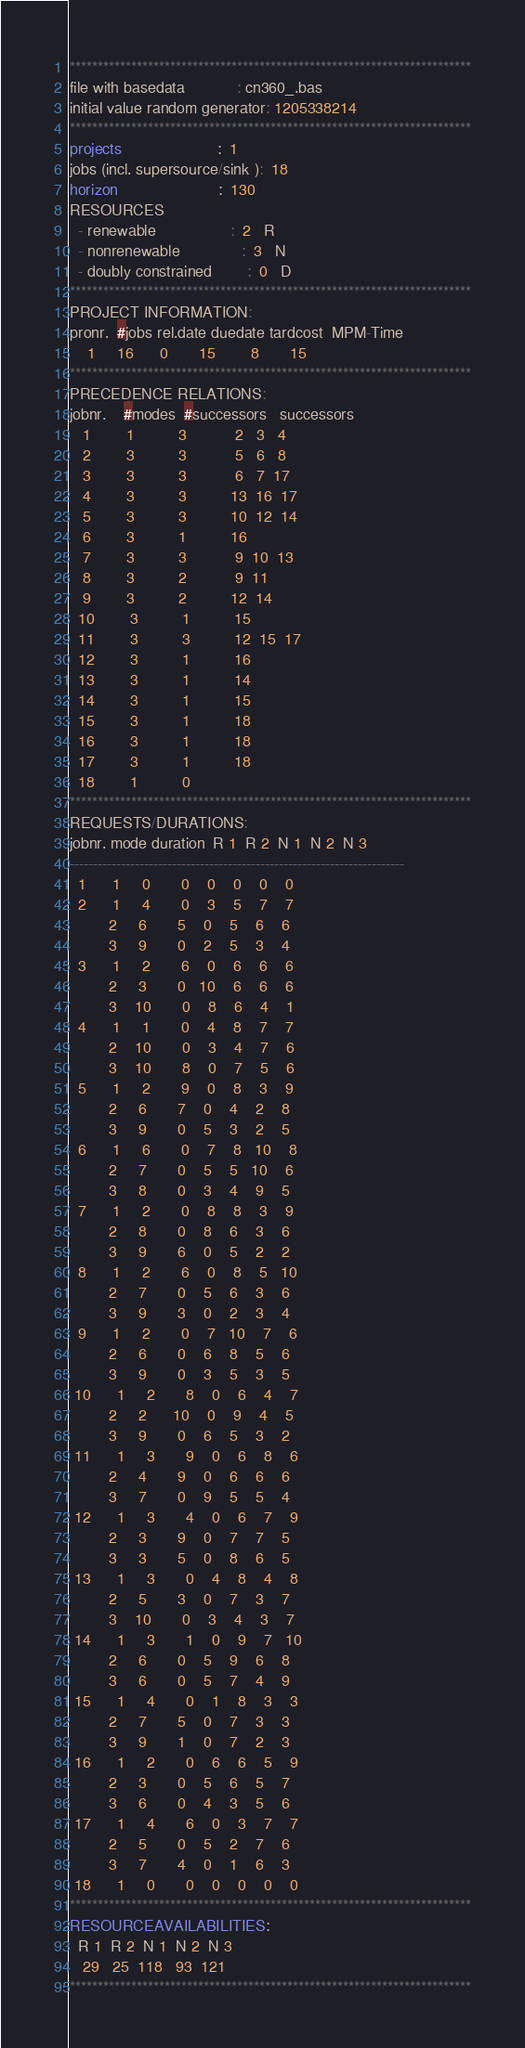<code> <loc_0><loc_0><loc_500><loc_500><_ObjectiveC_>************************************************************************
file with basedata            : cn360_.bas
initial value random generator: 1205338214
************************************************************************
projects                      :  1
jobs (incl. supersource/sink ):  18
horizon                       :  130
RESOURCES
  - renewable                 :  2   R
  - nonrenewable              :  3   N
  - doubly constrained        :  0   D
************************************************************************
PROJECT INFORMATION:
pronr.  #jobs rel.date duedate tardcost  MPM-Time
    1     16      0       15        8       15
************************************************************************
PRECEDENCE RELATIONS:
jobnr.    #modes  #successors   successors
   1        1          3           2   3   4
   2        3          3           5   6   8
   3        3          3           6   7  17
   4        3          3          13  16  17
   5        3          3          10  12  14
   6        3          1          16
   7        3          3           9  10  13
   8        3          2           9  11
   9        3          2          12  14
  10        3          1          15
  11        3          3          12  15  17
  12        3          1          16
  13        3          1          14
  14        3          1          15
  15        3          1          18
  16        3          1          18
  17        3          1          18
  18        1          0        
************************************************************************
REQUESTS/DURATIONS:
jobnr. mode duration  R 1  R 2  N 1  N 2  N 3
------------------------------------------------------------------------
  1      1     0       0    0    0    0    0
  2      1     4       0    3    5    7    7
         2     6       5    0    5    6    6
         3     9       0    2    5    3    4
  3      1     2       6    0    6    6    6
         2     3       0   10    6    6    6
         3    10       0    8    6    4    1
  4      1     1       0    4    8    7    7
         2    10       0    3    4    7    6
         3    10       8    0    7    5    6
  5      1     2       9    0    8    3    9
         2     6       7    0    4    2    8
         3     9       0    5    3    2    5
  6      1     6       0    7    8   10    8
         2     7       0    5    5   10    6
         3     8       0    3    4    9    5
  7      1     2       0    8    8    3    9
         2     8       0    8    6    3    6
         3     9       6    0    5    2    2
  8      1     2       6    0    8    5   10
         2     7       0    5    6    3    6
         3     9       3    0    2    3    4
  9      1     2       0    7   10    7    6
         2     6       0    6    8    5    6
         3     9       0    3    5    3    5
 10      1     2       8    0    6    4    7
         2     2      10    0    9    4    5
         3     9       0    6    5    3    2
 11      1     3       9    0    6    8    6
         2     4       9    0    6    6    6
         3     7       0    9    5    5    4
 12      1     3       4    0    6    7    9
         2     3       9    0    7    7    5
         3     3       5    0    8    6    5
 13      1     3       0    4    8    4    8
         2     5       3    0    7    3    7
         3    10       0    3    4    3    7
 14      1     3       1    0    9    7   10
         2     6       0    5    9    6    8
         3     6       0    5    7    4    9
 15      1     4       0    1    8    3    3
         2     7       5    0    7    3    3
         3     9       1    0    7    2    3
 16      1     2       0    6    6    5    9
         2     3       0    5    6    5    7
         3     6       0    4    3    5    6
 17      1     4       6    0    3    7    7
         2     5       0    5    2    7    6
         3     7       4    0    1    6    3
 18      1     0       0    0    0    0    0
************************************************************************
RESOURCEAVAILABILITIES:
  R 1  R 2  N 1  N 2  N 3
   29   25  118   93  121
************************************************************************
</code> 